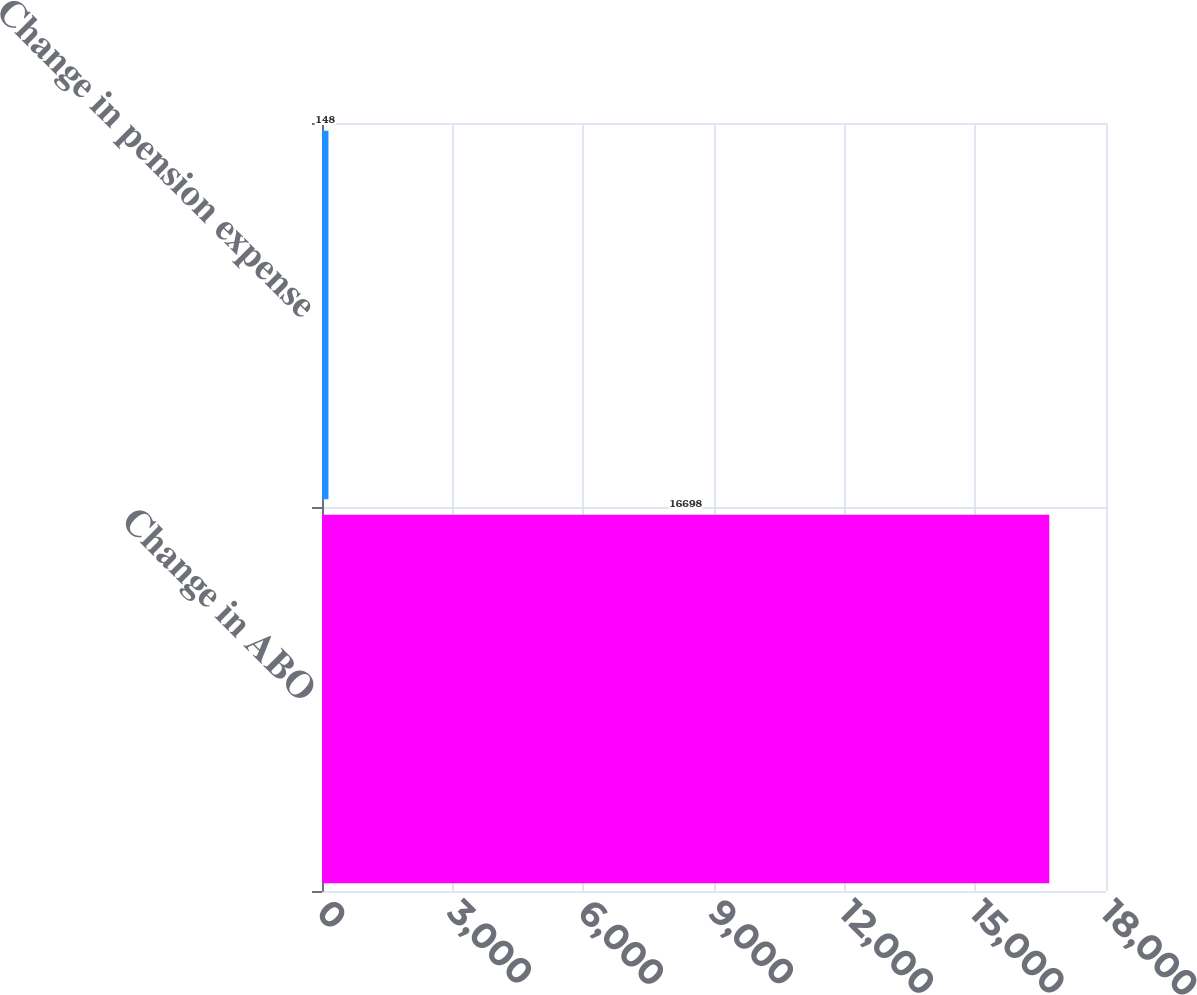<chart> <loc_0><loc_0><loc_500><loc_500><bar_chart><fcel>Change in ABO<fcel>Change in pension expense<nl><fcel>16698<fcel>148<nl></chart> 